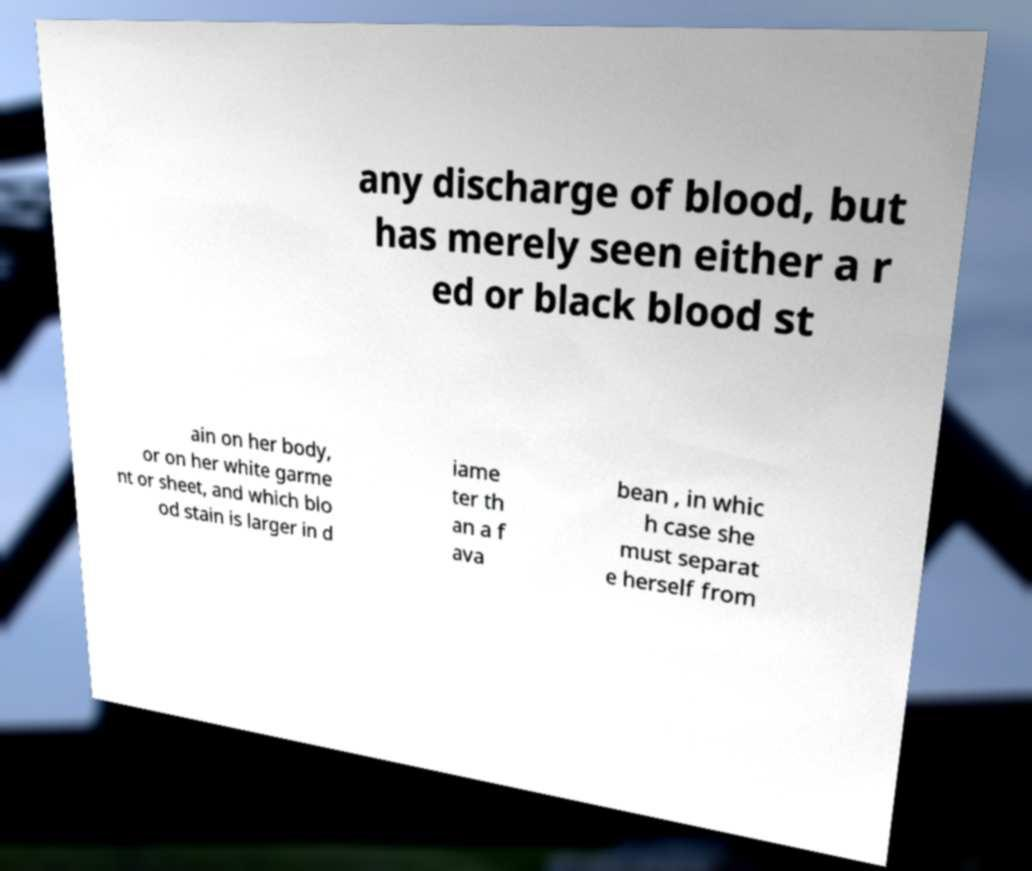Could you assist in decoding the text presented in this image and type it out clearly? any discharge of blood, but has merely seen either a r ed or black blood st ain on her body, or on her white garme nt or sheet, and which blo od stain is larger in d iame ter th an a f ava bean , in whic h case she must separat e herself from 